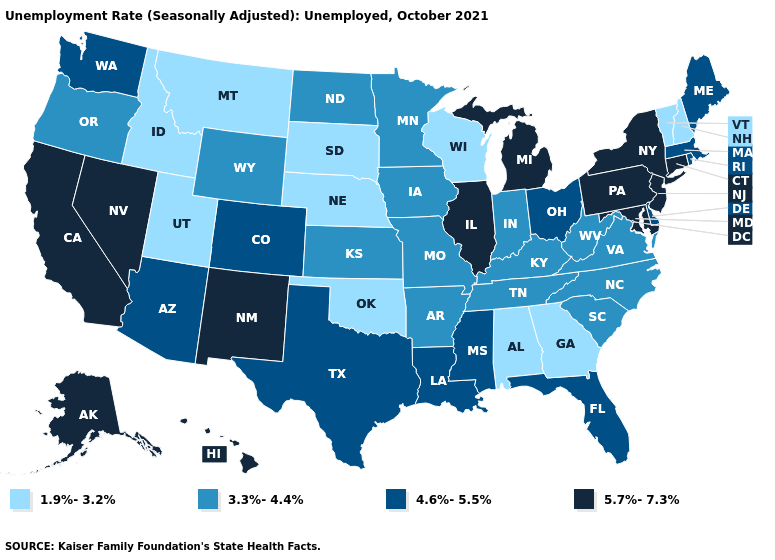Does New York have the lowest value in the Northeast?
Write a very short answer. No. Does Alaska have the lowest value in the West?
Answer briefly. No. Name the states that have a value in the range 3.3%-4.4%?
Short answer required. Arkansas, Indiana, Iowa, Kansas, Kentucky, Minnesota, Missouri, North Carolina, North Dakota, Oregon, South Carolina, Tennessee, Virginia, West Virginia, Wyoming. Does Utah have the lowest value in the West?
Be succinct. Yes. Does Alabama have the lowest value in the South?
Concise answer only. Yes. Name the states that have a value in the range 4.6%-5.5%?
Concise answer only. Arizona, Colorado, Delaware, Florida, Louisiana, Maine, Massachusetts, Mississippi, Ohio, Rhode Island, Texas, Washington. Which states hav the highest value in the West?
Write a very short answer. Alaska, California, Hawaii, Nevada, New Mexico. Name the states that have a value in the range 5.7%-7.3%?
Write a very short answer. Alaska, California, Connecticut, Hawaii, Illinois, Maryland, Michigan, Nevada, New Jersey, New Mexico, New York, Pennsylvania. What is the highest value in states that border Colorado?
Keep it brief. 5.7%-7.3%. Which states have the lowest value in the South?
Keep it brief. Alabama, Georgia, Oklahoma. Name the states that have a value in the range 3.3%-4.4%?
Quick response, please. Arkansas, Indiana, Iowa, Kansas, Kentucky, Minnesota, Missouri, North Carolina, North Dakota, Oregon, South Carolina, Tennessee, Virginia, West Virginia, Wyoming. What is the value of Louisiana?
Short answer required. 4.6%-5.5%. How many symbols are there in the legend?
Give a very brief answer. 4. Does Utah have the same value as California?
Write a very short answer. No. What is the value of Maine?
Be succinct. 4.6%-5.5%. 